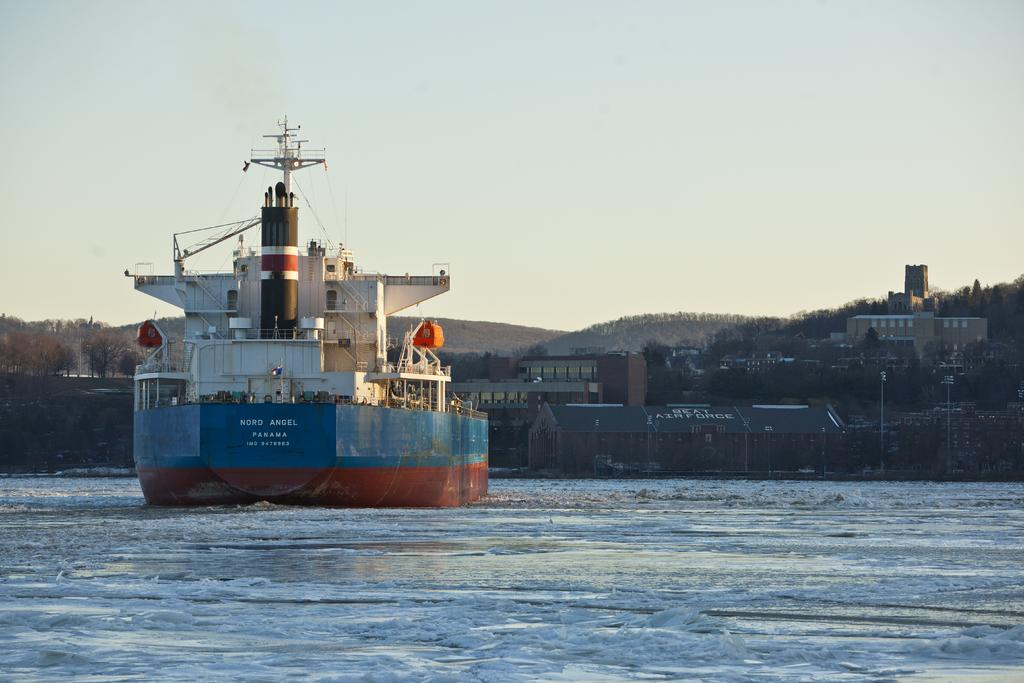What is the main subject of the image? The main subject of the image is a ship. Where is the ship located in the image? The ship is in the center of the image. What is the ship surrounded by? The ship is surrounded by water. What can be seen in the background of the image? There are trees, buildings, and poles in the background of the image. How many snails can be seen crawling on the ship in the image? There are no snails visible on the ship in the image. What type of shock can be felt by the people on the ship in the image? There is no indication of any shock or electrical disturbance in the image. 